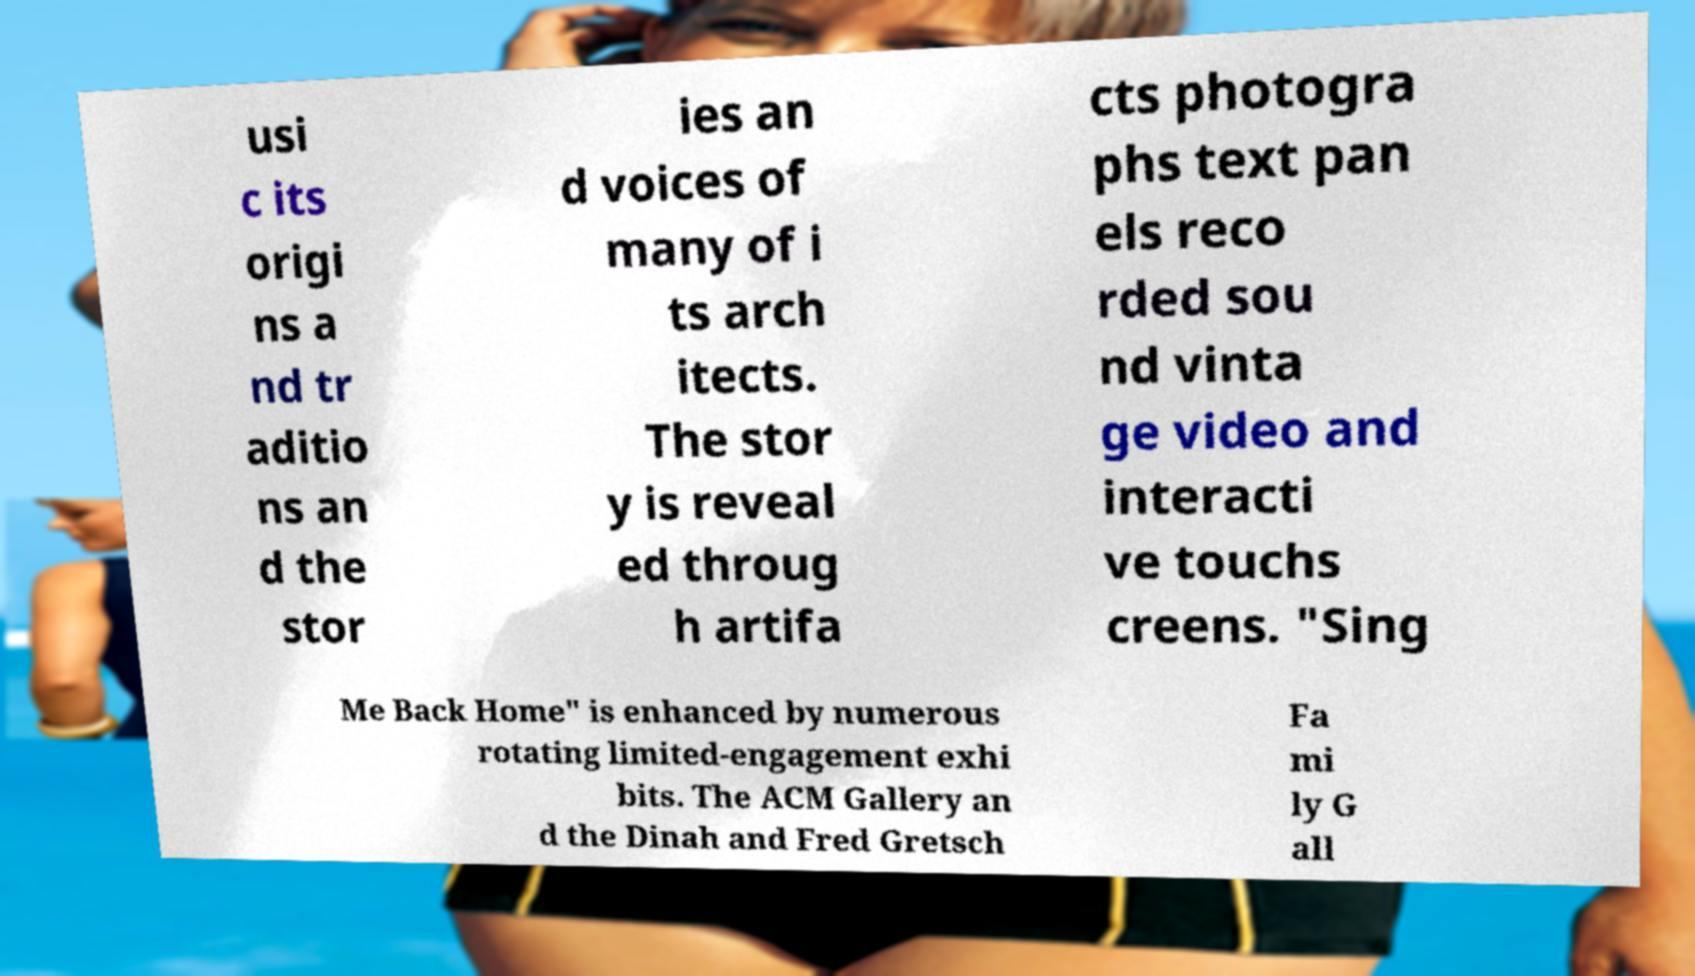I need the written content from this picture converted into text. Can you do that? usi c its origi ns a nd tr aditio ns an d the stor ies an d voices of many of i ts arch itects. The stor y is reveal ed throug h artifa cts photogra phs text pan els reco rded sou nd vinta ge video and interacti ve touchs creens. "Sing Me Back Home" is enhanced by numerous rotating limited-engagement exhi bits. The ACM Gallery an d the Dinah and Fred Gretsch Fa mi ly G all 